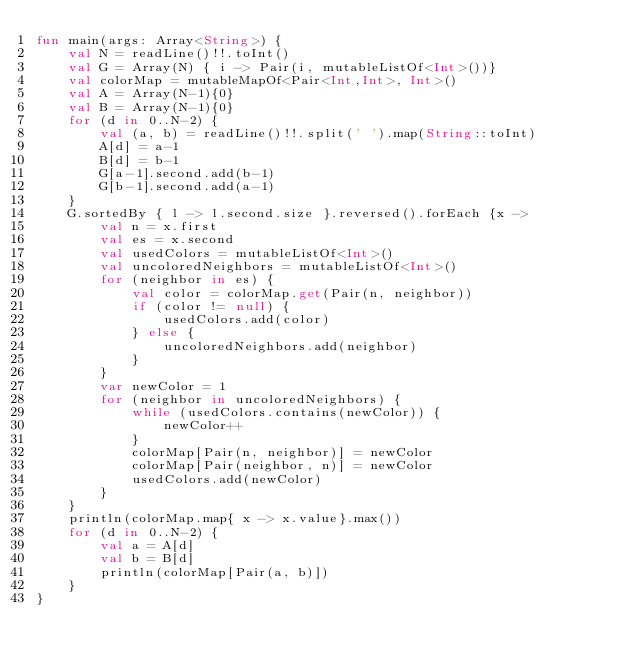Convert code to text. <code><loc_0><loc_0><loc_500><loc_500><_Kotlin_>fun main(args: Array<String>) {
    val N = readLine()!!.toInt()
    val G = Array(N) { i -> Pair(i, mutableListOf<Int>())}
    val colorMap = mutableMapOf<Pair<Int,Int>, Int>()
    val A = Array(N-1){0}
    val B = Array(N-1){0}
    for (d in 0..N-2) {
        val (a, b) = readLine()!!.split(' ').map(String::toInt)
        A[d] = a-1
        B[d] = b-1
        G[a-1].second.add(b-1)
        G[b-1].second.add(a-1)
    }
    G.sortedBy { l -> l.second.size }.reversed().forEach {x ->
        val n = x.first
        val es = x.second
        val usedColors = mutableListOf<Int>()
        val uncoloredNeighbors = mutableListOf<Int>()
        for (neighbor in es) {
            val color = colorMap.get(Pair(n, neighbor))
            if (color != null) {
                usedColors.add(color)
            } else {
                uncoloredNeighbors.add(neighbor)
            }
        }
        var newColor = 1
        for (neighbor in uncoloredNeighbors) {
            while (usedColors.contains(newColor)) {
                newColor++
            }
            colorMap[Pair(n, neighbor)] = newColor
            colorMap[Pair(neighbor, n)] = newColor
            usedColors.add(newColor)
        }
    }
    println(colorMap.map{ x -> x.value}.max())
    for (d in 0..N-2) {
        val a = A[d]
        val b = B[d]
        println(colorMap[Pair(a, b)])
    }
}</code> 